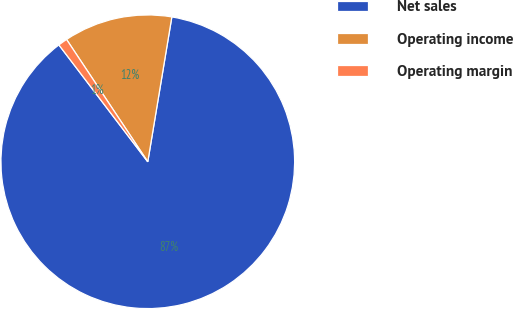Convert chart. <chart><loc_0><loc_0><loc_500><loc_500><pie_chart><fcel>Net sales<fcel>Operating income<fcel>Operating margin<nl><fcel>87.02%<fcel>11.95%<fcel>1.02%<nl></chart> 